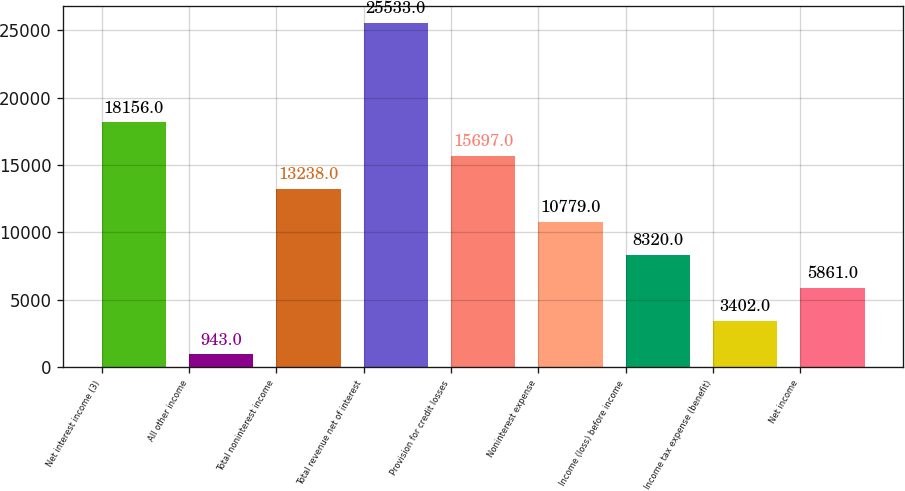<chart> <loc_0><loc_0><loc_500><loc_500><bar_chart><fcel>Net interest income (3)<fcel>All other income<fcel>Total noninterest income<fcel>Total revenue net of interest<fcel>Provision for credit losses<fcel>Noninterest expense<fcel>Income (loss) before income<fcel>Income tax expense (benefit)<fcel>Net income<nl><fcel>18156<fcel>943<fcel>13238<fcel>25533<fcel>15697<fcel>10779<fcel>8320<fcel>3402<fcel>5861<nl></chart> 